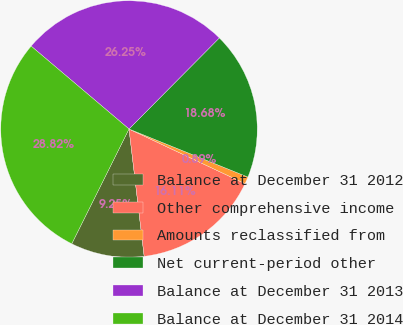<chart> <loc_0><loc_0><loc_500><loc_500><pie_chart><fcel>Balance at December 31 2012<fcel>Other comprehensive income<fcel>Amounts reclassified from<fcel>Net current-period other<fcel>Balance at December 31 2013<fcel>Balance at December 31 2014<nl><fcel>9.25%<fcel>16.11%<fcel>0.89%<fcel>18.68%<fcel>26.25%<fcel>28.82%<nl></chart> 